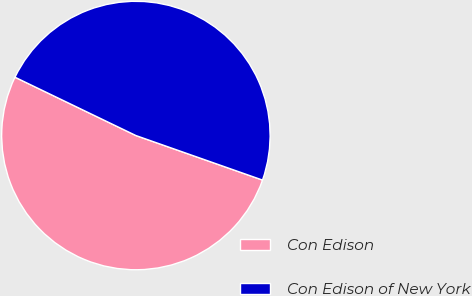Convert chart. <chart><loc_0><loc_0><loc_500><loc_500><pie_chart><fcel>Con Edison<fcel>Con Edison of New York<nl><fcel>51.77%<fcel>48.23%<nl></chart> 